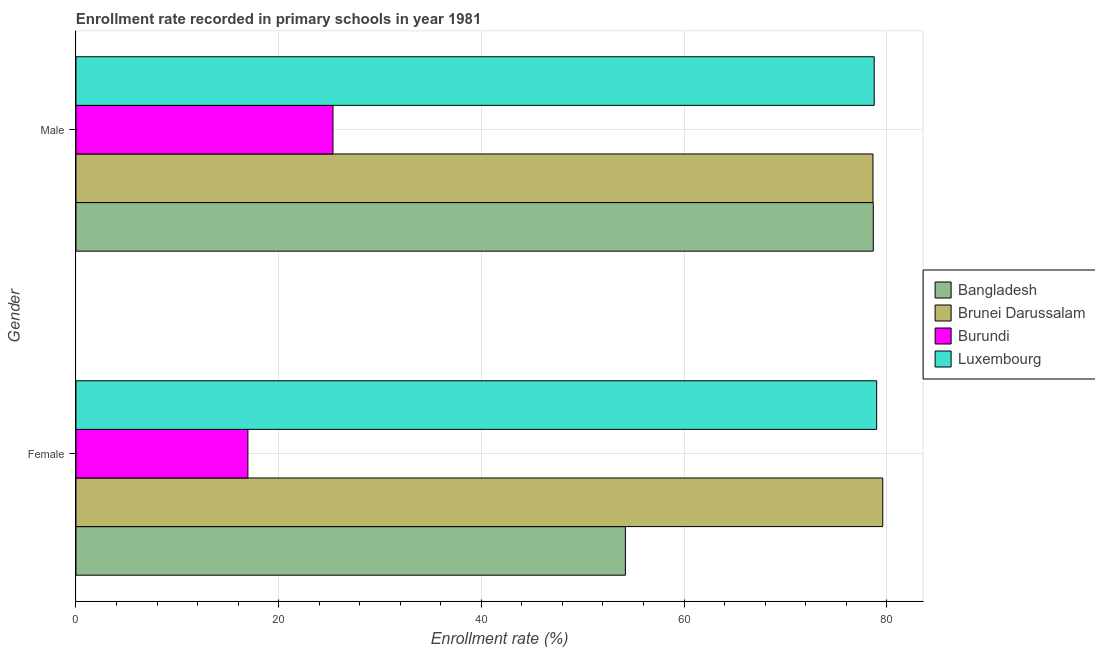Are the number of bars per tick equal to the number of legend labels?
Your answer should be compact. Yes. Are the number of bars on each tick of the Y-axis equal?
Offer a very short reply. Yes. How many bars are there on the 1st tick from the top?
Make the answer very short. 4. How many bars are there on the 1st tick from the bottom?
Offer a terse response. 4. What is the label of the 1st group of bars from the top?
Your answer should be very brief. Male. What is the enrollment rate of female students in Bangladesh?
Your answer should be very brief. 54.21. Across all countries, what is the maximum enrollment rate of male students?
Your response must be concise. 78.77. Across all countries, what is the minimum enrollment rate of male students?
Keep it short and to the point. 25.36. In which country was the enrollment rate of female students maximum?
Give a very brief answer. Brunei Darussalam. In which country was the enrollment rate of female students minimum?
Make the answer very short. Burundi. What is the total enrollment rate of female students in the graph?
Ensure brevity in your answer.  229.79. What is the difference between the enrollment rate of female students in Luxembourg and that in Bangladesh?
Provide a short and direct response. 24.8. What is the difference between the enrollment rate of male students in Luxembourg and the enrollment rate of female students in Bangladesh?
Ensure brevity in your answer.  24.55. What is the average enrollment rate of female students per country?
Offer a very short reply. 57.45. What is the difference between the enrollment rate of male students and enrollment rate of female students in Brunei Darussalam?
Offer a very short reply. -0.97. In how many countries, is the enrollment rate of male students greater than 68 %?
Ensure brevity in your answer.  3. What is the ratio of the enrollment rate of female students in Burundi to that in Luxembourg?
Keep it short and to the point. 0.21. Is the enrollment rate of female students in Luxembourg less than that in Brunei Darussalam?
Keep it short and to the point. Yes. What does the 3rd bar from the top in Female represents?
Provide a short and direct response. Brunei Darussalam. What does the 1st bar from the bottom in Female represents?
Your answer should be very brief. Bangladesh. How many bars are there?
Make the answer very short. 8. Are the values on the major ticks of X-axis written in scientific E-notation?
Provide a short and direct response. No. Does the graph contain any zero values?
Your answer should be very brief. No. Does the graph contain grids?
Offer a very short reply. Yes. What is the title of the graph?
Offer a very short reply. Enrollment rate recorded in primary schools in year 1981. What is the label or title of the X-axis?
Make the answer very short. Enrollment rate (%). What is the label or title of the Y-axis?
Provide a succinct answer. Gender. What is the Enrollment rate (%) of Bangladesh in Female?
Make the answer very short. 54.21. What is the Enrollment rate (%) of Brunei Darussalam in Female?
Offer a very short reply. 79.61. What is the Enrollment rate (%) of Burundi in Female?
Your response must be concise. 16.96. What is the Enrollment rate (%) in Luxembourg in Female?
Ensure brevity in your answer.  79.01. What is the Enrollment rate (%) of Bangladesh in Male?
Make the answer very short. 78.68. What is the Enrollment rate (%) of Brunei Darussalam in Male?
Offer a terse response. 78.64. What is the Enrollment rate (%) of Burundi in Male?
Your answer should be very brief. 25.36. What is the Enrollment rate (%) in Luxembourg in Male?
Give a very brief answer. 78.77. Across all Gender, what is the maximum Enrollment rate (%) of Bangladesh?
Provide a short and direct response. 78.68. Across all Gender, what is the maximum Enrollment rate (%) in Brunei Darussalam?
Your answer should be very brief. 79.61. Across all Gender, what is the maximum Enrollment rate (%) of Burundi?
Offer a very short reply. 25.36. Across all Gender, what is the maximum Enrollment rate (%) in Luxembourg?
Your answer should be compact. 79.01. Across all Gender, what is the minimum Enrollment rate (%) in Bangladesh?
Keep it short and to the point. 54.21. Across all Gender, what is the minimum Enrollment rate (%) in Brunei Darussalam?
Provide a short and direct response. 78.64. Across all Gender, what is the minimum Enrollment rate (%) of Burundi?
Make the answer very short. 16.96. Across all Gender, what is the minimum Enrollment rate (%) in Luxembourg?
Provide a succinct answer. 78.77. What is the total Enrollment rate (%) of Bangladesh in the graph?
Ensure brevity in your answer.  132.89. What is the total Enrollment rate (%) in Brunei Darussalam in the graph?
Offer a very short reply. 158.25. What is the total Enrollment rate (%) of Burundi in the graph?
Offer a terse response. 42.32. What is the total Enrollment rate (%) in Luxembourg in the graph?
Ensure brevity in your answer.  157.77. What is the difference between the Enrollment rate (%) of Bangladesh in Female and that in Male?
Your response must be concise. -24.46. What is the difference between the Enrollment rate (%) of Brunei Darussalam in Female and that in Male?
Your response must be concise. 0.97. What is the difference between the Enrollment rate (%) in Burundi in Female and that in Male?
Keep it short and to the point. -8.39. What is the difference between the Enrollment rate (%) in Luxembourg in Female and that in Male?
Ensure brevity in your answer.  0.24. What is the difference between the Enrollment rate (%) in Bangladesh in Female and the Enrollment rate (%) in Brunei Darussalam in Male?
Provide a short and direct response. -24.43. What is the difference between the Enrollment rate (%) of Bangladesh in Female and the Enrollment rate (%) of Burundi in Male?
Provide a short and direct response. 28.85. What is the difference between the Enrollment rate (%) of Bangladesh in Female and the Enrollment rate (%) of Luxembourg in Male?
Your answer should be very brief. -24.55. What is the difference between the Enrollment rate (%) of Brunei Darussalam in Female and the Enrollment rate (%) of Burundi in Male?
Offer a terse response. 54.25. What is the difference between the Enrollment rate (%) in Brunei Darussalam in Female and the Enrollment rate (%) in Luxembourg in Male?
Your answer should be very brief. 0.84. What is the difference between the Enrollment rate (%) of Burundi in Female and the Enrollment rate (%) of Luxembourg in Male?
Offer a terse response. -61.8. What is the average Enrollment rate (%) in Bangladesh per Gender?
Your response must be concise. 66.44. What is the average Enrollment rate (%) in Brunei Darussalam per Gender?
Your answer should be compact. 79.13. What is the average Enrollment rate (%) of Burundi per Gender?
Keep it short and to the point. 21.16. What is the average Enrollment rate (%) in Luxembourg per Gender?
Ensure brevity in your answer.  78.89. What is the difference between the Enrollment rate (%) in Bangladesh and Enrollment rate (%) in Brunei Darussalam in Female?
Make the answer very short. -25.4. What is the difference between the Enrollment rate (%) of Bangladesh and Enrollment rate (%) of Burundi in Female?
Provide a short and direct response. 37.25. What is the difference between the Enrollment rate (%) in Bangladesh and Enrollment rate (%) in Luxembourg in Female?
Your response must be concise. -24.8. What is the difference between the Enrollment rate (%) in Brunei Darussalam and Enrollment rate (%) in Burundi in Female?
Your answer should be compact. 62.65. What is the difference between the Enrollment rate (%) of Brunei Darussalam and Enrollment rate (%) of Luxembourg in Female?
Provide a succinct answer. 0.6. What is the difference between the Enrollment rate (%) of Burundi and Enrollment rate (%) of Luxembourg in Female?
Ensure brevity in your answer.  -62.04. What is the difference between the Enrollment rate (%) in Bangladesh and Enrollment rate (%) in Brunei Darussalam in Male?
Provide a succinct answer. 0.03. What is the difference between the Enrollment rate (%) in Bangladesh and Enrollment rate (%) in Burundi in Male?
Make the answer very short. 53.32. What is the difference between the Enrollment rate (%) in Bangladesh and Enrollment rate (%) in Luxembourg in Male?
Make the answer very short. -0.09. What is the difference between the Enrollment rate (%) in Brunei Darussalam and Enrollment rate (%) in Burundi in Male?
Your response must be concise. 53.28. What is the difference between the Enrollment rate (%) of Brunei Darussalam and Enrollment rate (%) of Luxembourg in Male?
Make the answer very short. -0.12. What is the difference between the Enrollment rate (%) in Burundi and Enrollment rate (%) in Luxembourg in Male?
Your answer should be very brief. -53.41. What is the ratio of the Enrollment rate (%) in Bangladesh in Female to that in Male?
Offer a terse response. 0.69. What is the ratio of the Enrollment rate (%) of Brunei Darussalam in Female to that in Male?
Offer a terse response. 1.01. What is the ratio of the Enrollment rate (%) in Burundi in Female to that in Male?
Your response must be concise. 0.67. What is the difference between the highest and the second highest Enrollment rate (%) of Bangladesh?
Give a very brief answer. 24.46. What is the difference between the highest and the second highest Enrollment rate (%) in Brunei Darussalam?
Provide a short and direct response. 0.97. What is the difference between the highest and the second highest Enrollment rate (%) of Burundi?
Make the answer very short. 8.39. What is the difference between the highest and the second highest Enrollment rate (%) of Luxembourg?
Keep it short and to the point. 0.24. What is the difference between the highest and the lowest Enrollment rate (%) in Bangladesh?
Make the answer very short. 24.46. What is the difference between the highest and the lowest Enrollment rate (%) in Brunei Darussalam?
Offer a very short reply. 0.97. What is the difference between the highest and the lowest Enrollment rate (%) in Burundi?
Provide a succinct answer. 8.39. What is the difference between the highest and the lowest Enrollment rate (%) of Luxembourg?
Your response must be concise. 0.24. 